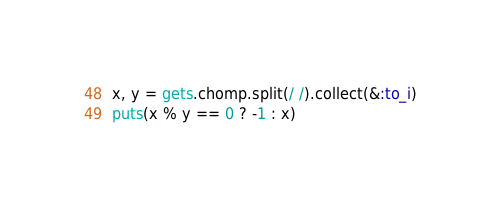<code> <loc_0><loc_0><loc_500><loc_500><_Ruby_>x, y = gets.chomp.split(/ /).collect(&:to_i)
puts(x % y == 0 ? -1 : x)</code> 